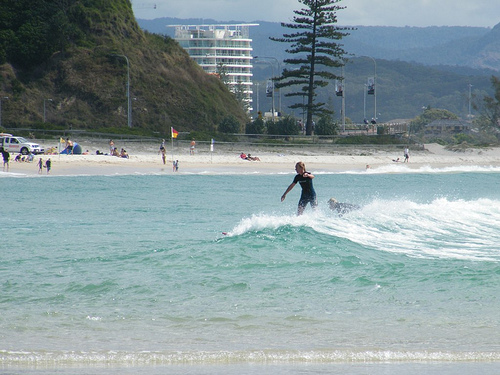How might this scene change with the seasons? Seasonal changes would transform this beach scene significantly. In summer, the beach is filled with people enjoying the warmth, engaging in water activities, and soaking up the sun. The water's waves would be inviting, perfect for surfing and swimming. In autumn, the scene might quiet down, with fewer beachgoers but more serene landscapes, leaves changing colors on the hillside, and cooler temperatures. Winter would bring a starker change, with the beach nearly deserted, waves potentially rougher, and the water too cold for most swimmers, though die-hard surfers might still brave the icy waves. Spring would rejuvenate the scene slowly, as temperatures rise and the first few brave beachgoers and surfers return, enjoying the fresh blooms on the hillside and the gradually warming waters. Describe the scene on a snowy winter day. On a snowy winter day, the beach takes on a mystical, almost surreal appearance. The sandy shore is blanketed by a thin layer of pristine, sparkling snow. The waves crash against the shore with ferocity, their frothy tips mingling with the snow-covered sand. The air is brisk and biting, with a crisp coldness that turns every breath into visible puffs of vapor. Most of the usual crowd is absent, with only a few solitary figures braving the chill, bundled in warm winter coats, perhaps walking their dogs or capturing the rare snowy beach scene with their cameras. The vibrant greens of the hillside are muted under a light snowfall, and the building in the background stands stoic against the stark white background. The lifeguard vehicle, now more of a ghostly presence, sits unused on the beach. The flag flutters stiffly, frozen by the cold air, marking the spot that once buzzed with summertime energy. 